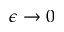Convert formula to latex. <formula><loc_0><loc_0><loc_500><loc_500>\epsilon \rightarrow 0</formula> 